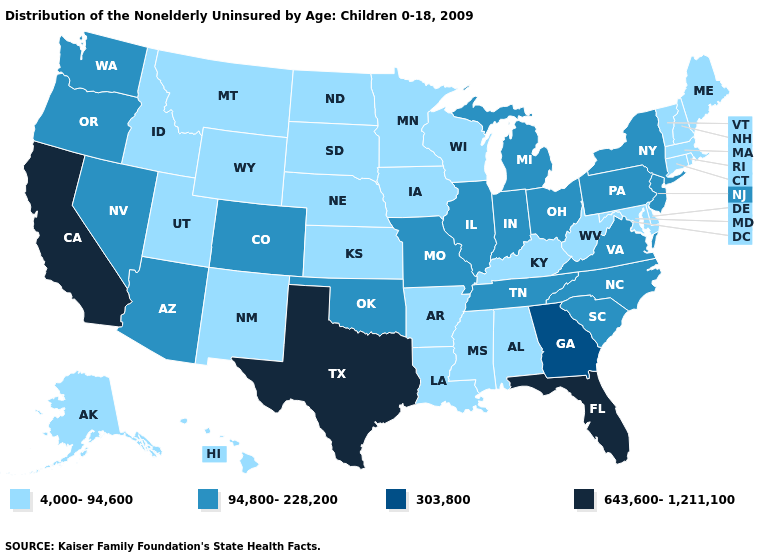What is the lowest value in the Northeast?
Keep it brief. 4,000-94,600. Which states have the lowest value in the West?
Quick response, please. Alaska, Hawaii, Idaho, Montana, New Mexico, Utah, Wyoming. Among the states that border Mississippi , does Alabama have the lowest value?
Short answer required. Yes. How many symbols are there in the legend?
Concise answer only. 4. Does the first symbol in the legend represent the smallest category?
Answer briefly. Yes. Name the states that have a value in the range 4,000-94,600?
Quick response, please. Alabama, Alaska, Arkansas, Connecticut, Delaware, Hawaii, Idaho, Iowa, Kansas, Kentucky, Louisiana, Maine, Maryland, Massachusetts, Minnesota, Mississippi, Montana, Nebraska, New Hampshire, New Mexico, North Dakota, Rhode Island, South Dakota, Utah, Vermont, West Virginia, Wisconsin, Wyoming. What is the value of Alaska?
Answer briefly. 4,000-94,600. Name the states that have a value in the range 643,600-1,211,100?
Answer briefly. California, Florida, Texas. Among the states that border Delaware , does Maryland have the lowest value?
Short answer required. Yes. Is the legend a continuous bar?
Concise answer only. No. Which states hav the highest value in the Northeast?
Give a very brief answer. New Jersey, New York, Pennsylvania. Does Ohio have the lowest value in the MidWest?
Be succinct. No. Name the states that have a value in the range 643,600-1,211,100?
Be succinct. California, Florida, Texas. Name the states that have a value in the range 303,800?
Write a very short answer. Georgia. Name the states that have a value in the range 4,000-94,600?
Answer briefly. Alabama, Alaska, Arkansas, Connecticut, Delaware, Hawaii, Idaho, Iowa, Kansas, Kentucky, Louisiana, Maine, Maryland, Massachusetts, Minnesota, Mississippi, Montana, Nebraska, New Hampshire, New Mexico, North Dakota, Rhode Island, South Dakota, Utah, Vermont, West Virginia, Wisconsin, Wyoming. 